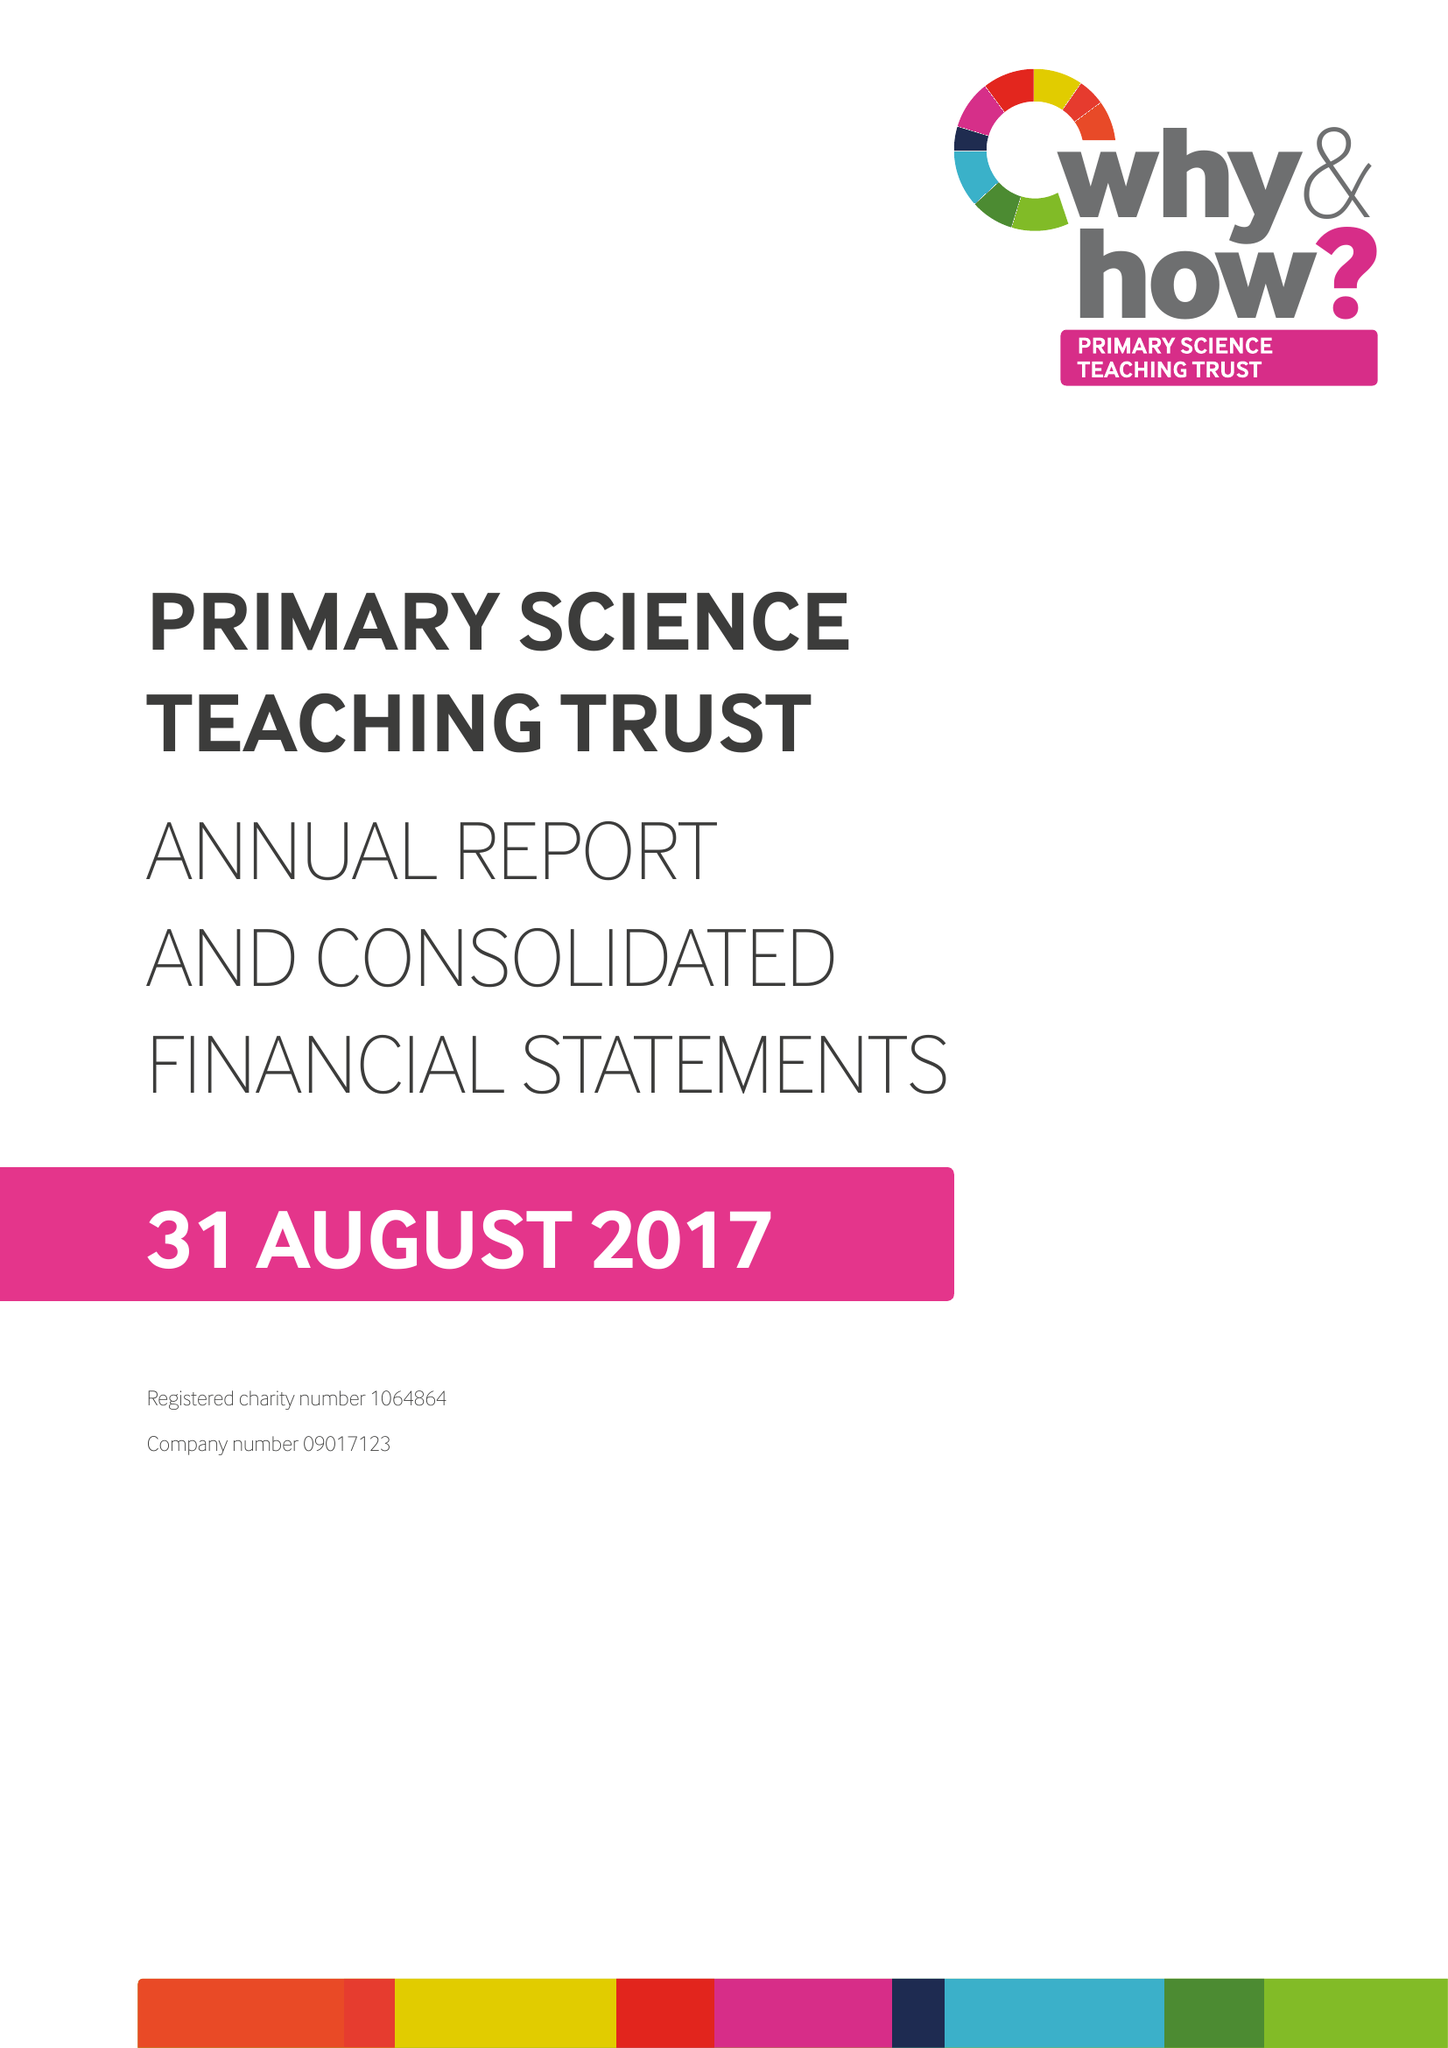What is the value for the address__street_line?
Answer the question using a single word or phrase. None 